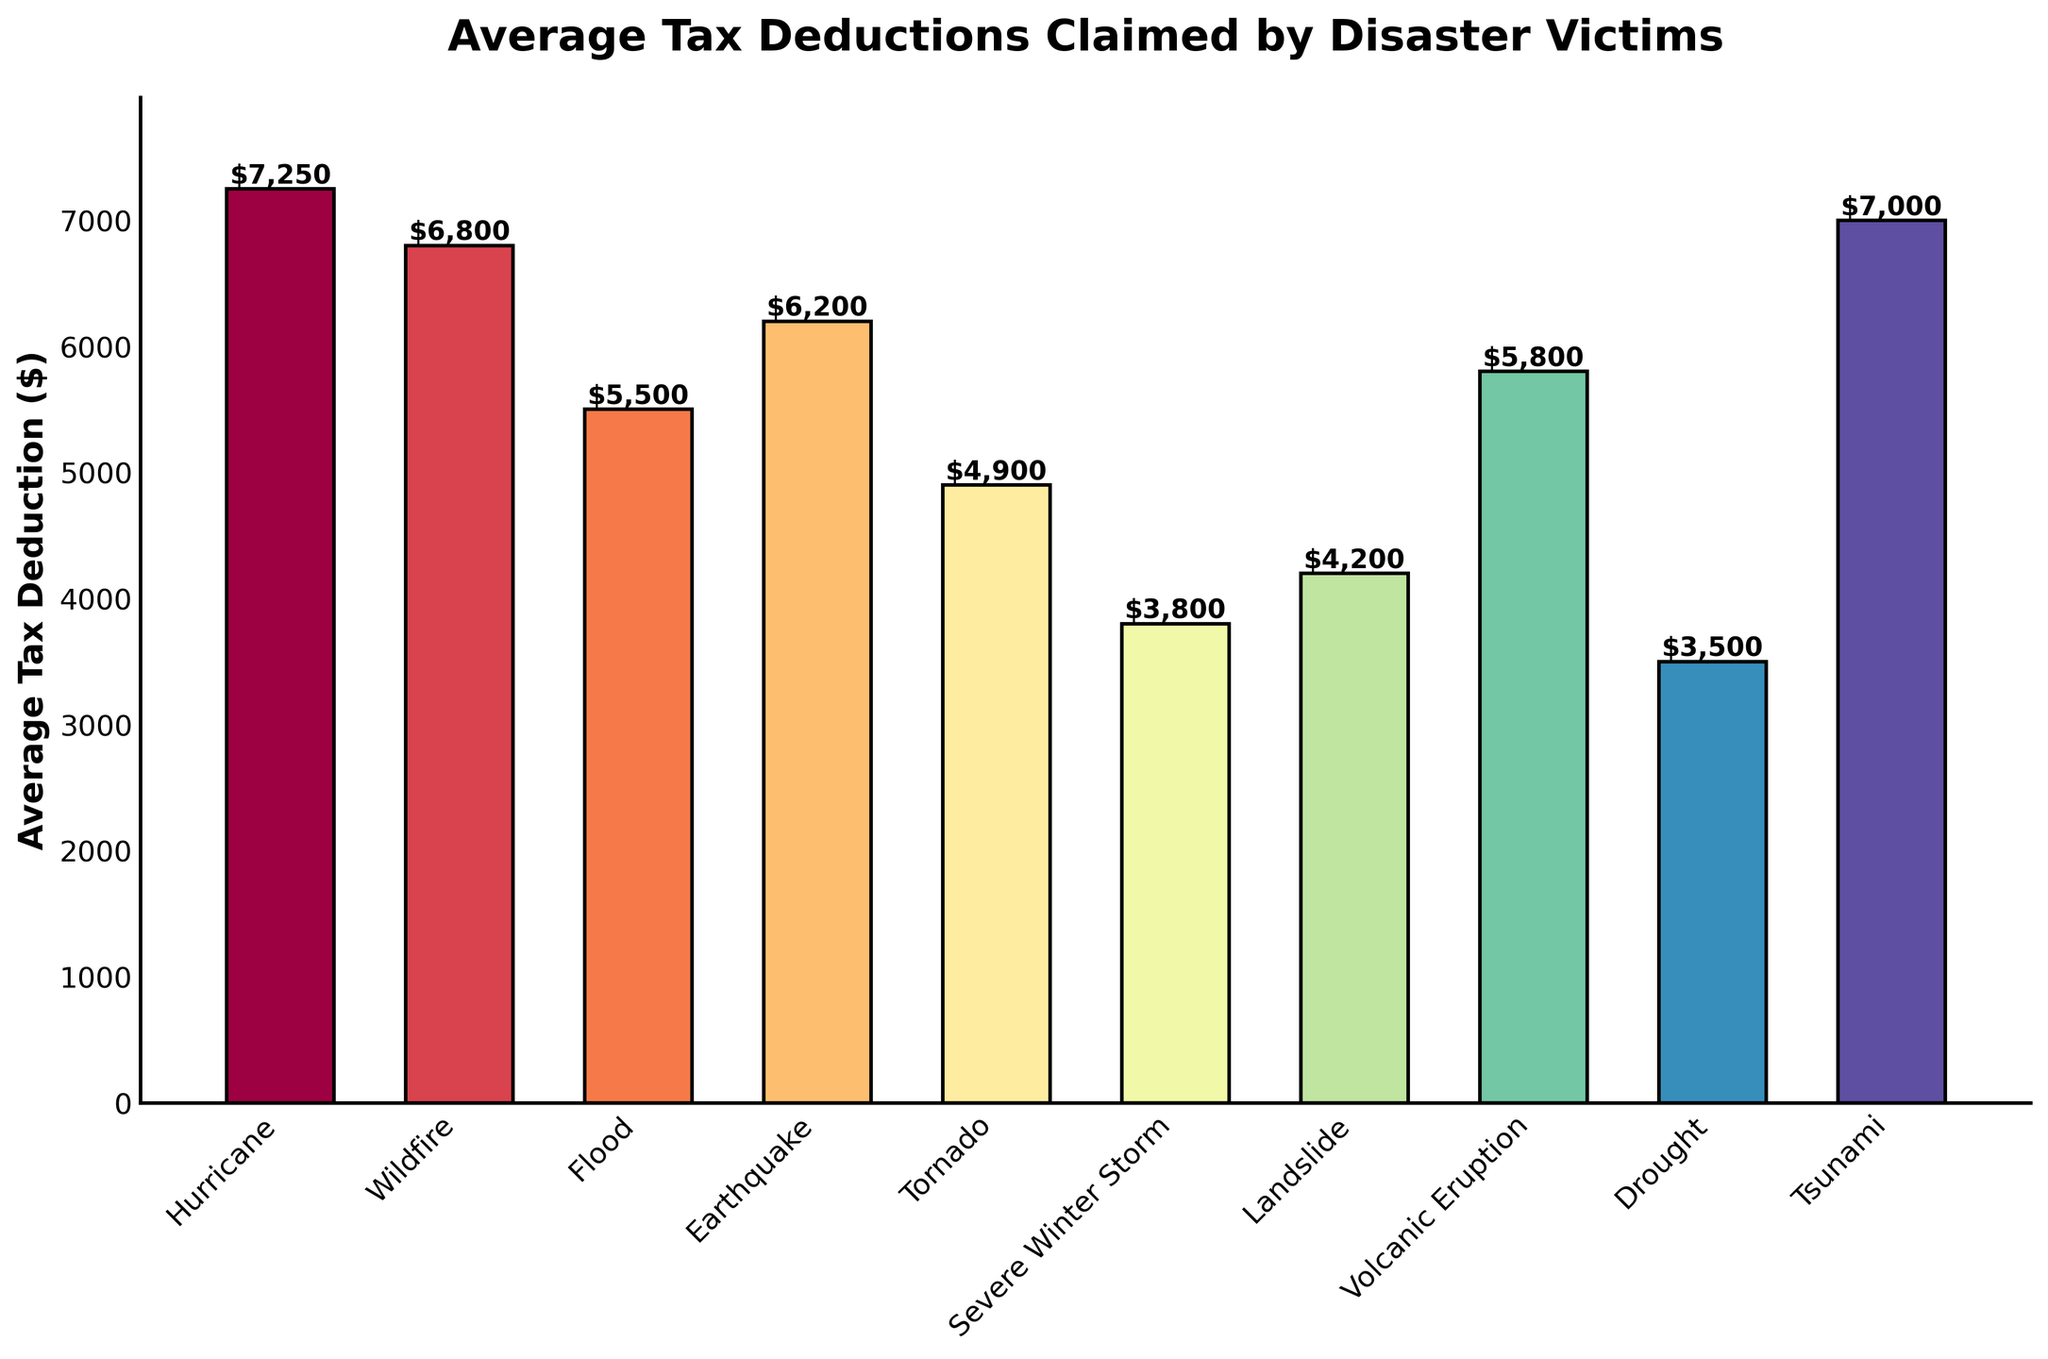Which disaster type has the highest average tax deduction? Looking at the height of the bars, the bar representing "Hurricane" is the tallest among all, indicating the highest average tax deduction.
Answer: Hurricane Which two disaster types have the smallest average tax deductions? Observing the shortest bars, "Severe Winter Storm" and "Drought" show the lowest heights, representing the smallest average tax deductions.
Answer: Severe Winter Storm and Drought What is the difference in average tax deductions between a Hurricane and a Severe Winter Storm? The average tax deduction for Hurricane is $7,250, and for Severe Winter Storm is $3,800. By subtracting $3,800 from $7,250, we get $3,450.
Answer: $3,450 Which is greater: the average tax deduction for a Flood or a Tsunami? Comparing the heights of the bars, the bar for "Tsunami" is taller than that of "Flood," meaning the average tax deduction is greater for a Tsunami.
Answer: Tsunami Which disaster types have average tax deductions of over $6,000? The disaster types with bars surpassing the $6,000 line are "Hurricane," "Tsunami," "Wildfire," and "Earthquake."
Answer: Hurricane, Tsunami, Wildfire, and Earthquake By how much does the average tax deduction for a Tornado fall short of that for an Earthquake? The average tax deduction for Tornado is $4,900 and for Earthquake is $6,200. The difference is $6,200 - $4,900 = $1,300.
Answer: $1,300 What is the combined average tax deduction for Landslides and Droughts? The average tax deductions for Landslide and Drought are $4,200 and $3,500, respectively. Summing them up gives $4,200 + $3,500 = $7,700.
Answer: $7,700 If you sum the average tax deductions for Wildfires, Floods, and Volcanic Eruptions, what is the total? The average tax deductions are $6,800 for Wildfire, $5,500 for Flood, and $5,800 for Volcanic Eruption. Adding them together: $6,800 + $5,500 + $5,800 = $18,100.
Answer: $18,100 What is the average (mean) average tax deduction for all the disaster types listed? First, sum all average tax deductions: $7,250 + $6,800 + $5,500 + $6,200 + $4,900 + $3,800 + $4,200 + $5,800 + $3,500 + $7,000 = $54,950. There are 10 disaster types, so the mean is $54,950 / 10 = $5,495.
Answer: $5,495 Which disaster type is colored the second from the highest hue in the bar chart? Observing the color gradient used in the bars, the second highest hue (right after "Hurricane") belongs to the "Tsunami" bar.
Answer: Tsunami 